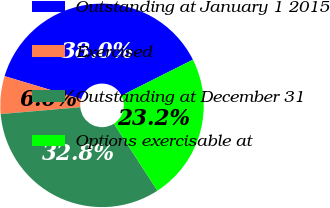<chart> <loc_0><loc_0><loc_500><loc_500><pie_chart><fcel>Outstanding at January 1 2015<fcel>Exercised<fcel>Outstanding at December 31<fcel>Options exercisable at<nl><fcel>37.95%<fcel>6.0%<fcel>32.81%<fcel>23.24%<nl></chart> 